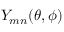Convert formula to latex. <formula><loc_0><loc_0><loc_500><loc_500>Y _ { m n } ( \theta , \phi )</formula> 